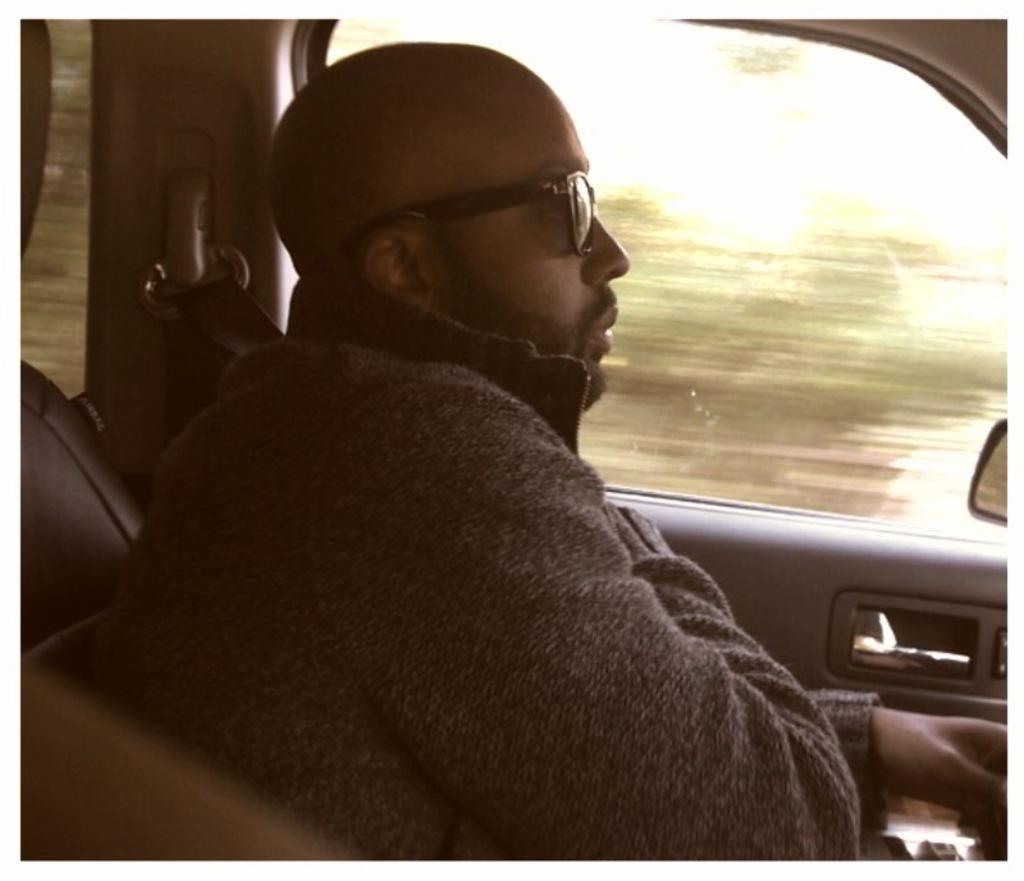What is the man in the image doing? The man is seated in the front seat of a vehicle. What is the man wearing that is visible in the image? The man is wearing sunglasses. What can be seen through the window in the vehicle? The image does not provide enough information to determine what can be seen through the window. What feature is present on the side of the vehicle? There is a side mirror in the vehicle. What type of plants can be seen growing inside the vehicle? There are no plants visible inside the vehicle in the image. 